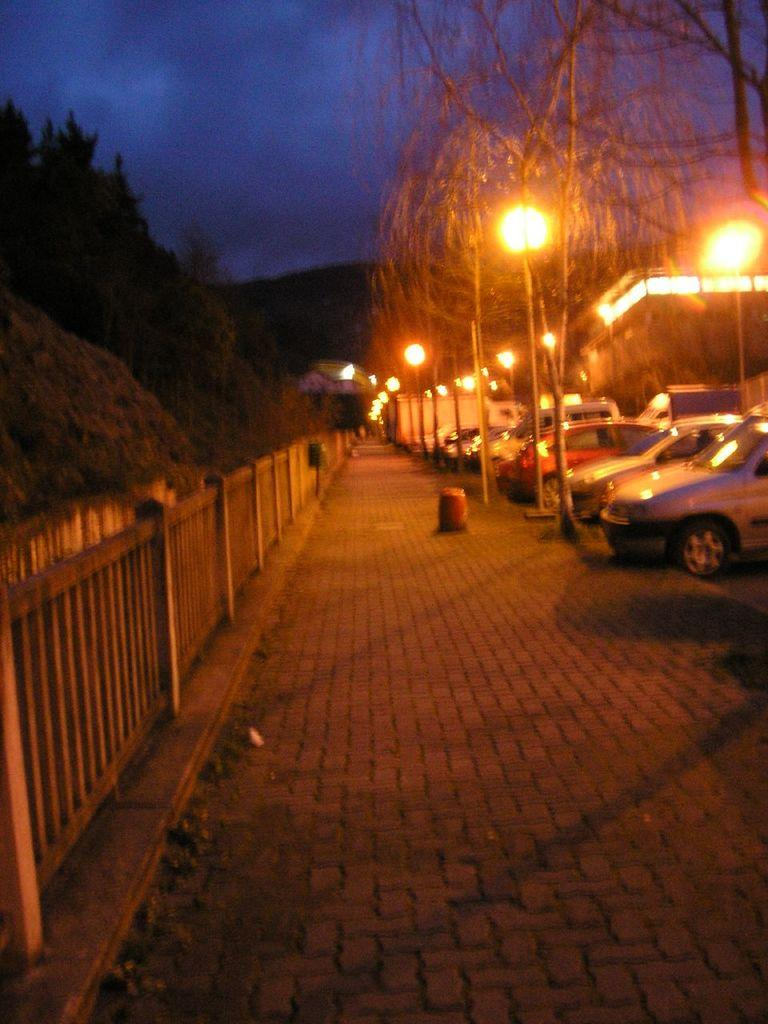What can be seen parked in the image? There are cars parked in the image. What type of lighting is present on the sidewalk? There are pole lights on the sidewalk. What type of vegetation is present on either side of the image? There are trees on either side of the image. What type of building is visible in the image? There is a house in the image. What type of barrier is present in the image? There is a wooden fence in the image. What is the condition of the sky in the image? The sky is cloudy in the image. How much wealth is represented by the cars in the image? The value or wealth of the cars cannot be determined from the image alone. What type of tax is associated with the wooden fence in the image? There is no mention of taxes in the image, and the wooden fence is not associated with any tax. 